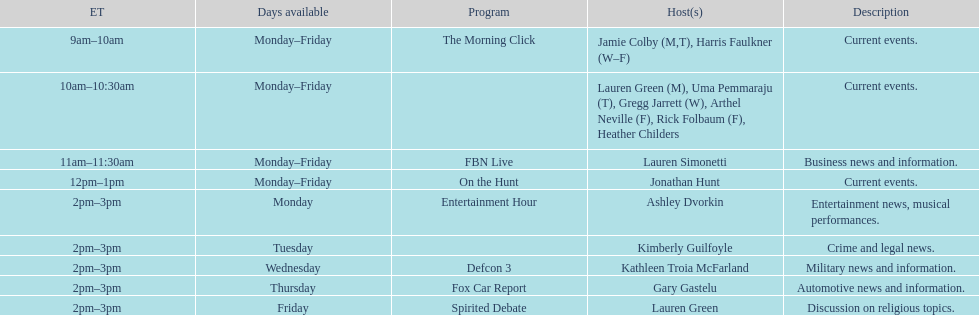How long does the show defcon 3 last? 1 hour. 